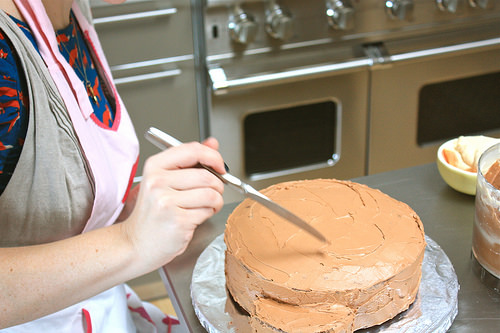<image>
Is there a cake on the table? Yes. Looking at the image, I can see the cake is positioned on top of the table, with the table providing support. Where is the cake in relation to the oven? Is it behind the oven? No. The cake is not behind the oven. From this viewpoint, the cake appears to be positioned elsewhere in the scene. Where is the baker in relation to the cake? Is it above the cake? Yes. The baker is positioned above the cake in the vertical space, higher up in the scene. 